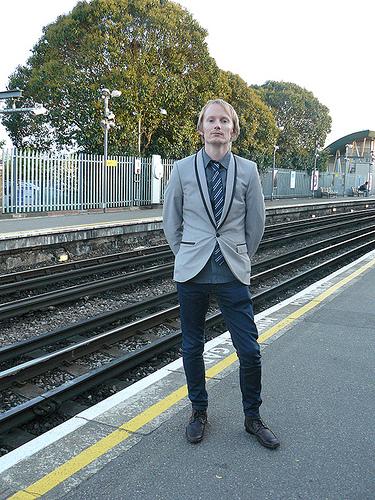What color is the man's tie?
Be succinct. Blue. What is this man standing next to?
Short answer required. Train tracks. Is he smiling?
Be succinct. No. Is this man wearing sneakers?
Give a very brief answer. No. 